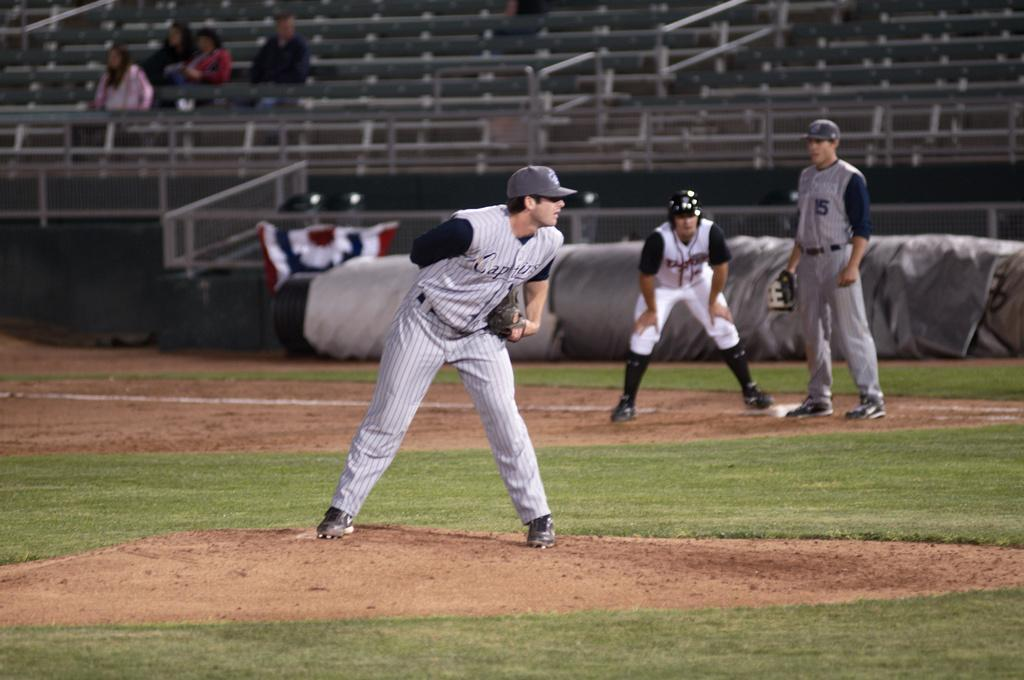How many people are playing baseball in the image? There are three players in the image. What sport are the players engaged in? The players are playing baseball. Can you describe the background of the image? There are four members sitting on benches in the background of the image. What type of coal is being used to fuel the volleyball game in the image? There is no coal or volleyball game present in the image; it features a baseball game. Can you describe the magical powers being displayed by the players in the image? There is no mention of magic or magical powers in the image; it features a baseball game. 